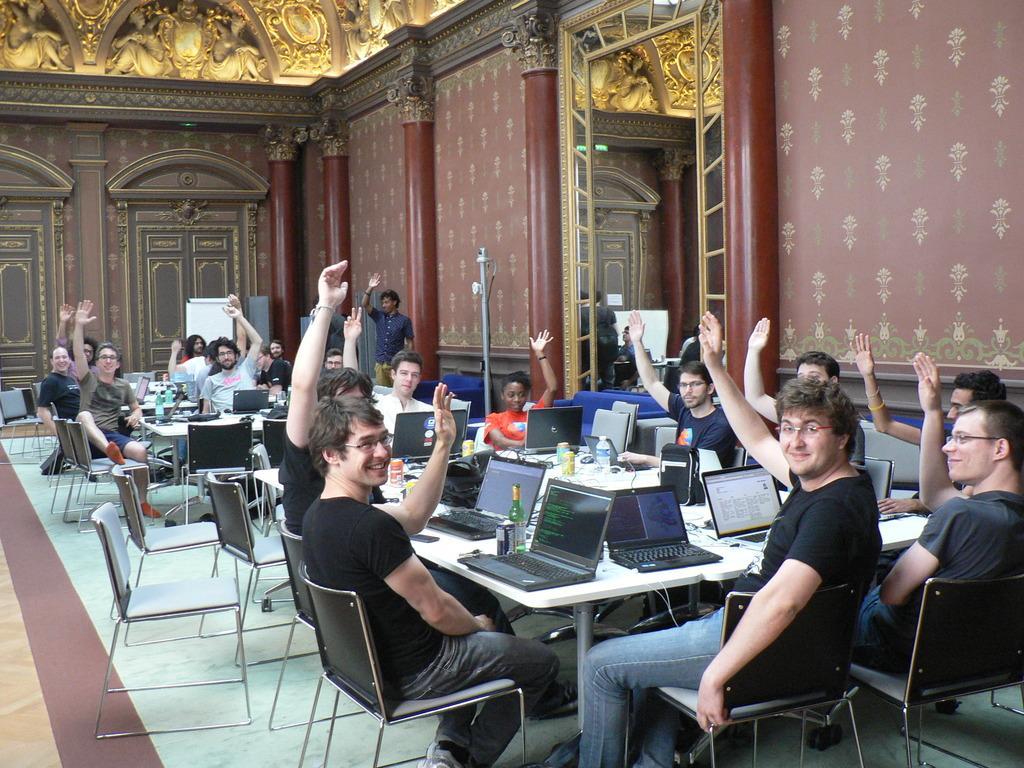Please provide a concise description of this image. In a picture so many people are sitting and raising their hands and in front of them there is a big table on which there are laptops and wine bottles,water bottles are present and behind them there is a big wall and a middle door and at the left corner there is one white board near the wall and there is one person standing and in the other one person is standing in front of the white board and there are statues on the roof. 